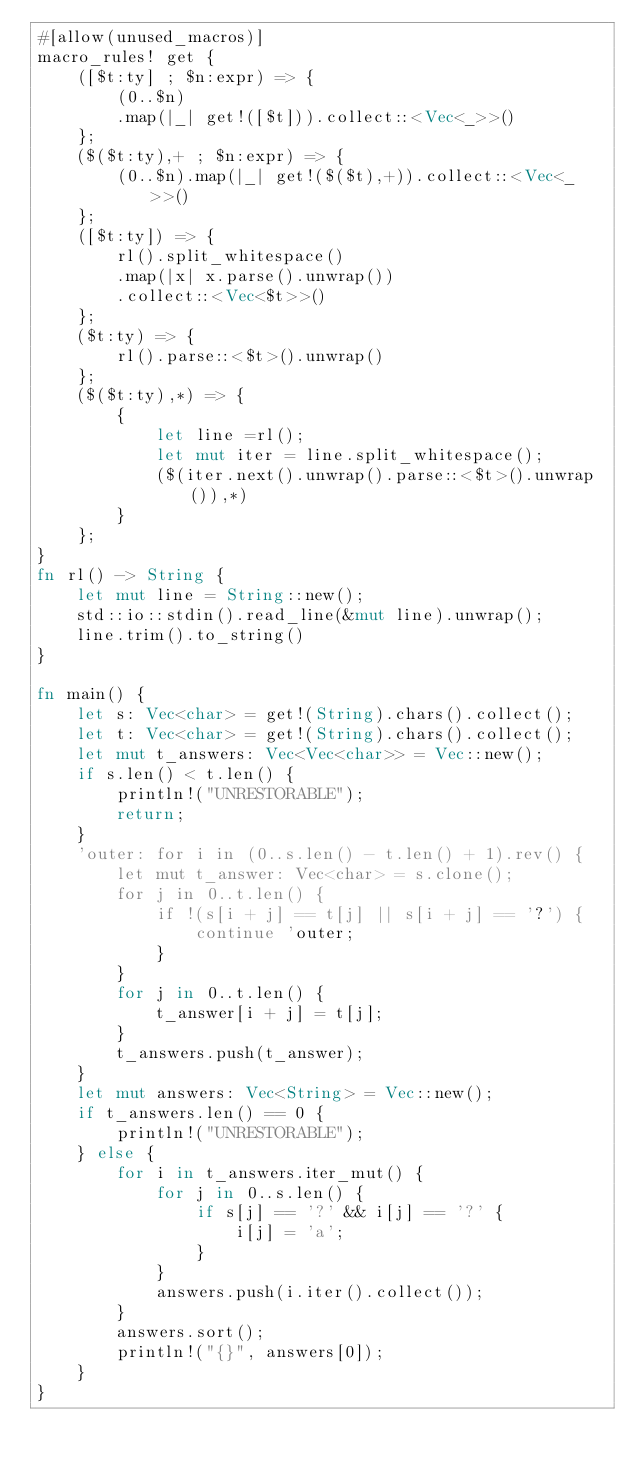Convert code to text. <code><loc_0><loc_0><loc_500><loc_500><_Rust_>#[allow(unused_macros)]
macro_rules! get {
    ([$t:ty] ; $n:expr) => {
        (0..$n)
        .map(|_| get!([$t])).collect::<Vec<_>>()
    };
    ($($t:ty),+ ; $n:expr) => {
        (0..$n).map(|_| get!($($t),+)).collect::<Vec<_>>()
    };
    ([$t:ty]) => {
        rl().split_whitespace()
        .map(|x| x.parse().unwrap())
        .collect::<Vec<$t>>()
    };
    ($t:ty) => {
        rl().parse::<$t>().unwrap()
    };
    ($($t:ty),*) => {
        {
            let line =rl();
            let mut iter = line.split_whitespace();
            ($(iter.next().unwrap().parse::<$t>().unwrap()),*)
        }
    };
}
fn rl() -> String {
    let mut line = String::new();
    std::io::stdin().read_line(&mut line).unwrap();
    line.trim().to_string()
}

fn main() {
    let s: Vec<char> = get!(String).chars().collect();
    let t: Vec<char> = get!(String).chars().collect();
    let mut t_answers: Vec<Vec<char>> = Vec::new();
    if s.len() < t.len() {
        println!("UNRESTORABLE");
        return;
    }
    'outer: for i in (0..s.len() - t.len() + 1).rev() {
        let mut t_answer: Vec<char> = s.clone();
        for j in 0..t.len() {
            if !(s[i + j] == t[j] || s[i + j] == '?') {
                continue 'outer;
            }
        }
        for j in 0..t.len() {
            t_answer[i + j] = t[j];
        }
        t_answers.push(t_answer);
    }
    let mut answers: Vec<String> = Vec::new();
    if t_answers.len() == 0 {
        println!("UNRESTORABLE");
    } else {
        for i in t_answers.iter_mut() {
            for j in 0..s.len() {
                if s[j] == '?' && i[j] == '?' {
                    i[j] = 'a';
                }
            }
            answers.push(i.iter().collect());
        }
        answers.sort();
        println!("{}", answers[0]);
    }
}
</code> 